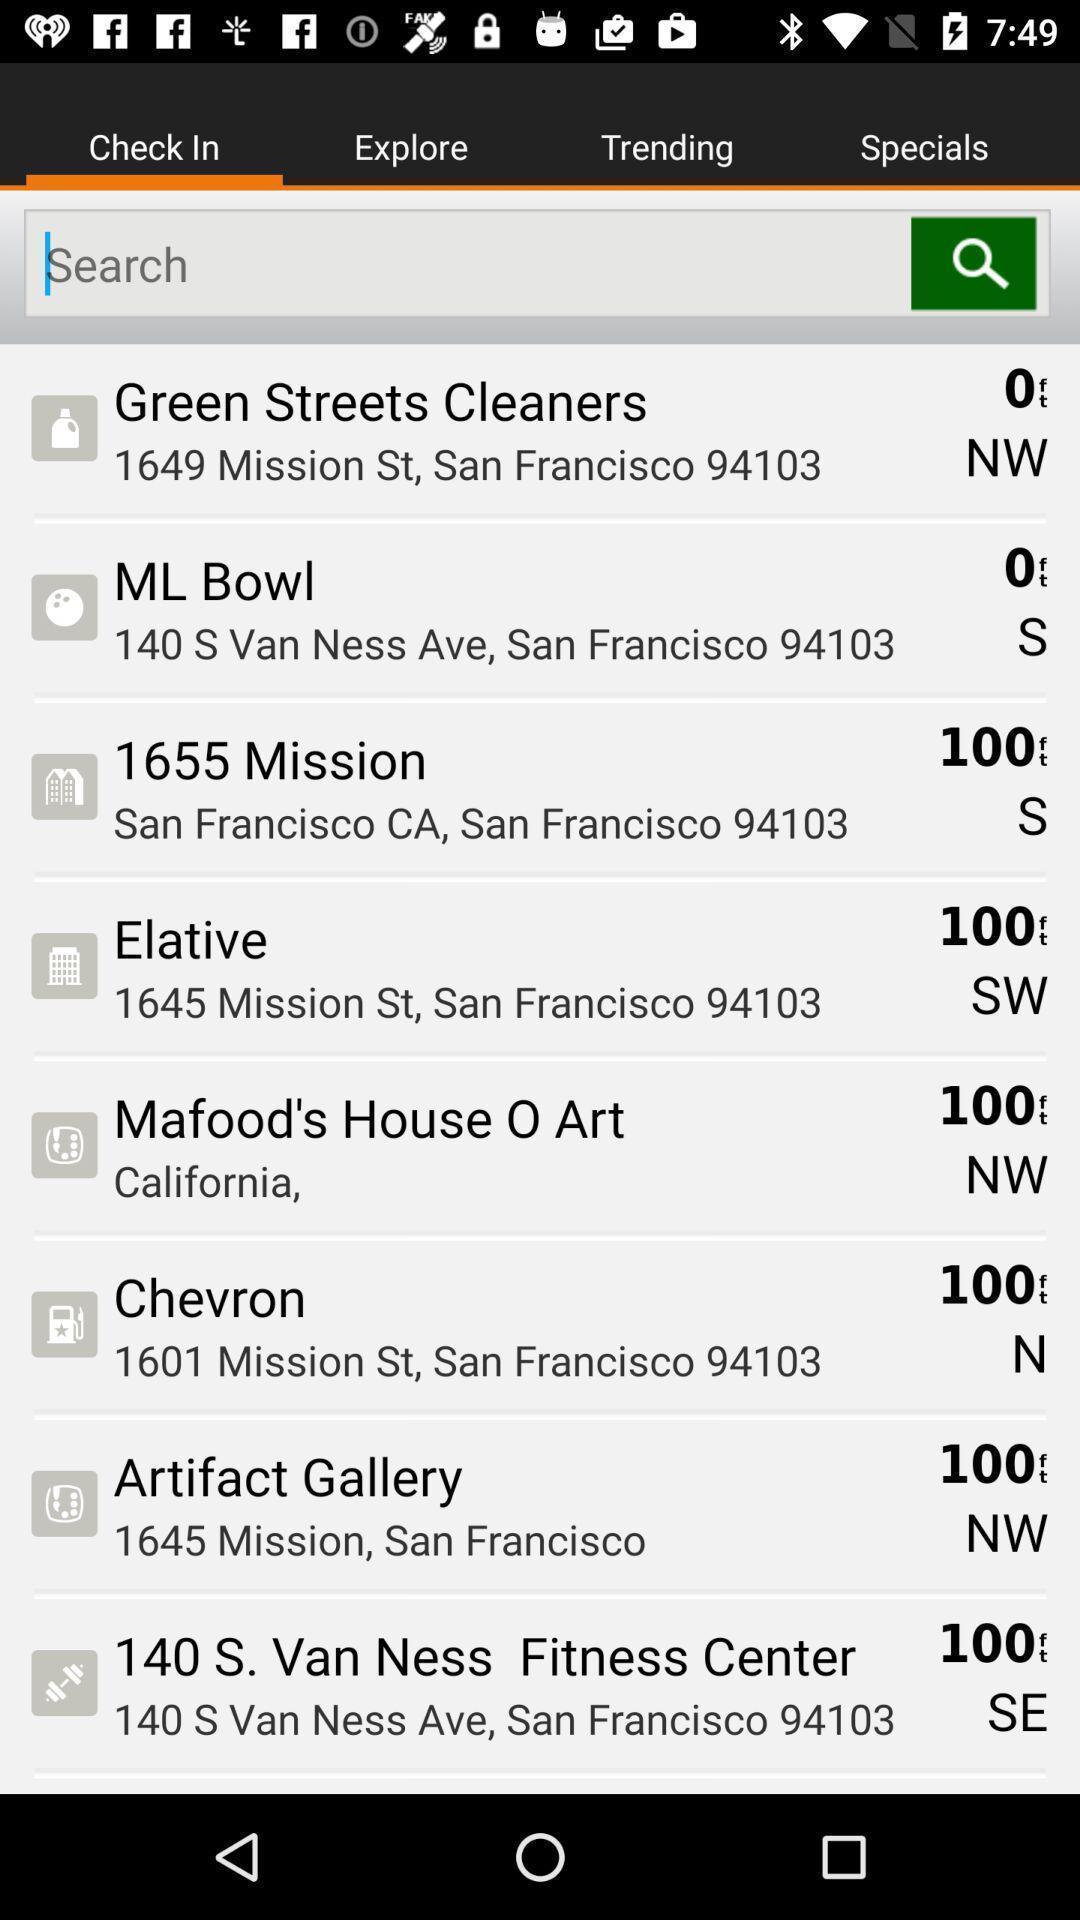Provide a description of this screenshot. Screen displaying multiple locations information and a search bar. 